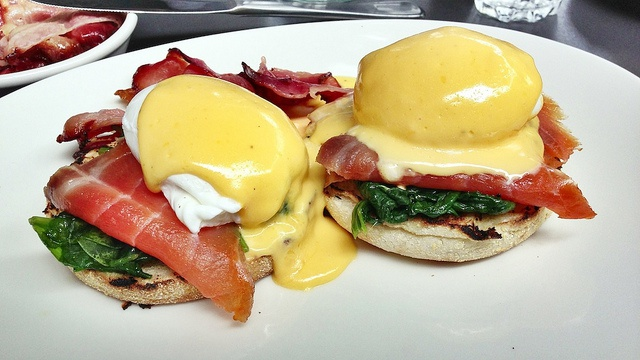Describe the objects in this image and their specific colors. I can see sandwich in tan, khaki, and ivory tones, dining table in tan, gray, black, white, and darkgray tones, broccoli in tan, black, darkgreen, and maroon tones, knife in tan, gray, black, darkgray, and lightgray tones, and cup in tan, lightgray, darkgray, and gray tones in this image. 